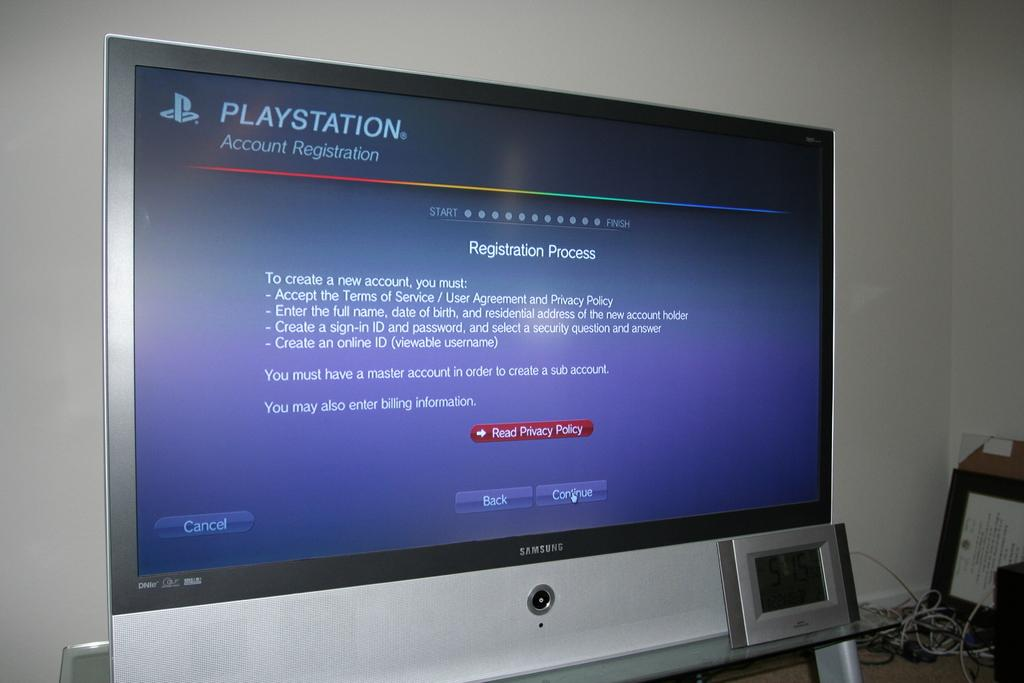<image>
Offer a succinct explanation of the picture presented. A large screen displays a Playstation Account Registration page with a blue background. 